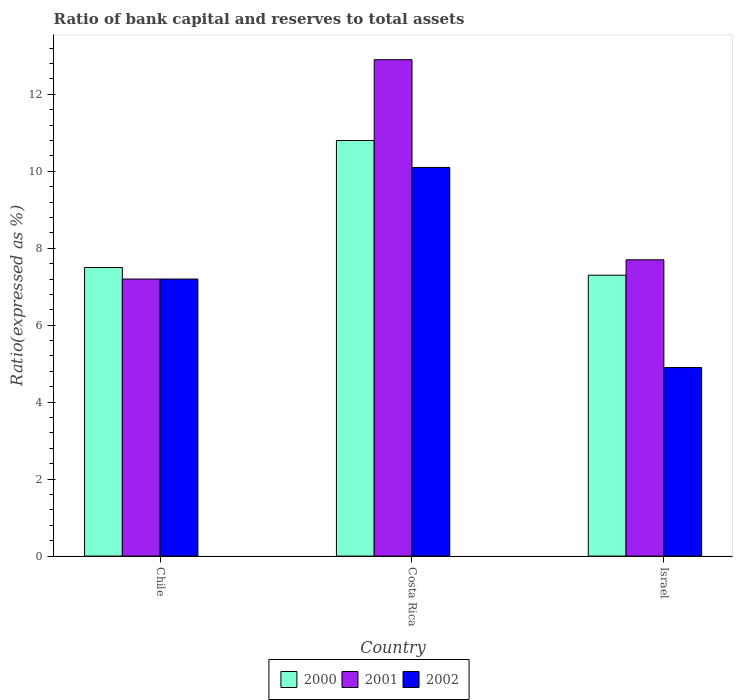Are the number of bars on each tick of the X-axis equal?
Ensure brevity in your answer.  Yes. How many bars are there on the 3rd tick from the left?
Keep it short and to the point. 3. How many bars are there on the 1st tick from the right?
Your response must be concise. 3. In how many cases, is the number of bars for a given country not equal to the number of legend labels?
Offer a terse response. 0. Across all countries, what is the maximum ratio of bank capital and reserves to total assets in 2002?
Offer a very short reply. 10.1. What is the total ratio of bank capital and reserves to total assets in 2002 in the graph?
Offer a very short reply. 22.2. What is the difference between the ratio of bank capital and reserves to total assets in 2001 in Chile and that in Israel?
Make the answer very short. -0.5. What is the average ratio of bank capital and reserves to total assets in 2001 per country?
Make the answer very short. 9.27. What is the difference between the ratio of bank capital and reserves to total assets of/in 2000 and ratio of bank capital and reserves to total assets of/in 2001 in Israel?
Ensure brevity in your answer.  -0.4. What is the ratio of the ratio of bank capital and reserves to total assets in 2000 in Chile to that in Costa Rica?
Offer a terse response. 0.69. Is the ratio of bank capital and reserves to total assets in 2002 in Chile less than that in Costa Rica?
Keep it short and to the point. Yes. What is the difference between the highest and the lowest ratio of bank capital and reserves to total assets in 2000?
Provide a succinct answer. 3.5. What does the 2nd bar from the left in Costa Rica represents?
Your answer should be very brief. 2001. What does the 2nd bar from the right in Chile represents?
Give a very brief answer. 2001. Is it the case that in every country, the sum of the ratio of bank capital and reserves to total assets in 2002 and ratio of bank capital and reserves to total assets in 2000 is greater than the ratio of bank capital and reserves to total assets in 2001?
Provide a succinct answer. Yes. Are all the bars in the graph horizontal?
Provide a succinct answer. No. How many countries are there in the graph?
Offer a very short reply. 3. Are the values on the major ticks of Y-axis written in scientific E-notation?
Make the answer very short. No. What is the title of the graph?
Give a very brief answer. Ratio of bank capital and reserves to total assets. Does "1966" appear as one of the legend labels in the graph?
Keep it short and to the point. No. What is the label or title of the X-axis?
Offer a terse response. Country. What is the label or title of the Y-axis?
Keep it short and to the point. Ratio(expressed as %). What is the Ratio(expressed as %) of 2002 in Chile?
Your answer should be compact. 7.2. Across all countries, what is the minimum Ratio(expressed as %) of 2002?
Your response must be concise. 4.9. What is the total Ratio(expressed as %) in 2000 in the graph?
Your answer should be compact. 25.6. What is the total Ratio(expressed as %) of 2001 in the graph?
Keep it short and to the point. 27.8. What is the total Ratio(expressed as %) of 2002 in the graph?
Your response must be concise. 22.2. What is the difference between the Ratio(expressed as %) of 2000 in Chile and that in Costa Rica?
Your answer should be compact. -3.3. What is the difference between the Ratio(expressed as %) in 2001 in Chile and that in Israel?
Provide a short and direct response. -0.5. What is the difference between the Ratio(expressed as %) of 2002 in Chile and that in Israel?
Your answer should be compact. 2.3. What is the difference between the Ratio(expressed as %) of 2002 in Costa Rica and that in Israel?
Make the answer very short. 5.2. What is the difference between the Ratio(expressed as %) in 2000 in Chile and the Ratio(expressed as %) in 2001 in Costa Rica?
Make the answer very short. -5.4. What is the difference between the Ratio(expressed as %) of 2000 in Chile and the Ratio(expressed as %) of 2002 in Costa Rica?
Your response must be concise. -2.6. What is the difference between the Ratio(expressed as %) of 2000 in Chile and the Ratio(expressed as %) of 2001 in Israel?
Provide a succinct answer. -0.2. What is the difference between the Ratio(expressed as %) in 2000 in Chile and the Ratio(expressed as %) in 2002 in Israel?
Make the answer very short. 2.6. What is the difference between the Ratio(expressed as %) in 2001 in Chile and the Ratio(expressed as %) in 2002 in Israel?
Your response must be concise. 2.3. What is the difference between the Ratio(expressed as %) in 2000 in Costa Rica and the Ratio(expressed as %) in 2001 in Israel?
Make the answer very short. 3.1. What is the difference between the Ratio(expressed as %) in 2000 in Costa Rica and the Ratio(expressed as %) in 2002 in Israel?
Your response must be concise. 5.9. What is the difference between the Ratio(expressed as %) in 2001 in Costa Rica and the Ratio(expressed as %) in 2002 in Israel?
Make the answer very short. 8. What is the average Ratio(expressed as %) in 2000 per country?
Provide a succinct answer. 8.53. What is the average Ratio(expressed as %) of 2001 per country?
Offer a terse response. 9.27. What is the average Ratio(expressed as %) in 2002 per country?
Ensure brevity in your answer.  7.4. What is the difference between the Ratio(expressed as %) of 2000 and Ratio(expressed as %) of 2002 in Chile?
Offer a terse response. 0.3. What is the difference between the Ratio(expressed as %) in 2000 and Ratio(expressed as %) in 2001 in Costa Rica?
Ensure brevity in your answer.  -2.1. What is the difference between the Ratio(expressed as %) in 2001 and Ratio(expressed as %) in 2002 in Costa Rica?
Offer a very short reply. 2.8. What is the difference between the Ratio(expressed as %) in 2000 and Ratio(expressed as %) in 2002 in Israel?
Your response must be concise. 2.4. What is the difference between the Ratio(expressed as %) in 2001 and Ratio(expressed as %) in 2002 in Israel?
Ensure brevity in your answer.  2.8. What is the ratio of the Ratio(expressed as %) of 2000 in Chile to that in Costa Rica?
Provide a short and direct response. 0.69. What is the ratio of the Ratio(expressed as %) of 2001 in Chile to that in Costa Rica?
Provide a succinct answer. 0.56. What is the ratio of the Ratio(expressed as %) of 2002 in Chile to that in Costa Rica?
Provide a short and direct response. 0.71. What is the ratio of the Ratio(expressed as %) of 2000 in Chile to that in Israel?
Your answer should be compact. 1.03. What is the ratio of the Ratio(expressed as %) in 2001 in Chile to that in Israel?
Provide a succinct answer. 0.94. What is the ratio of the Ratio(expressed as %) in 2002 in Chile to that in Israel?
Make the answer very short. 1.47. What is the ratio of the Ratio(expressed as %) in 2000 in Costa Rica to that in Israel?
Make the answer very short. 1.48. What is the ratio of the Ratio(expressed as %) in 2001 in Costa Rica to that in Israel?
Your answer should be very brief. 1.68. What is the ratio of the Ratio(expressed as %) of 2002 in Costa Rica to that in Israel?
Provide a short and direct response. 2.06. What is the difference between the highest and the second highest Ratio(expressed as %) of 2000?
Your answer should be very brief. 3.3. What is the difference between the highest and the second highest Ratio(expressed as %) in 2001?
Your response must be concise. 5.2. What is the difference between the highest and the second highest Ratio(expressed as %) of 2002?
Offer a very short reply. 2.9. What is the difference between the highest and the lowest Ratio(expressed as %) of 2000?
Your response must be concise. 3.5. What is the difference between the highest and the lowest Ratio(expressed as %) of 2001?
Offer a terse response. 5.7. What is the difference between the highest and the lowest Ratio(expressed as %) of 2002?
Your answer should be very brief. 5.2. 